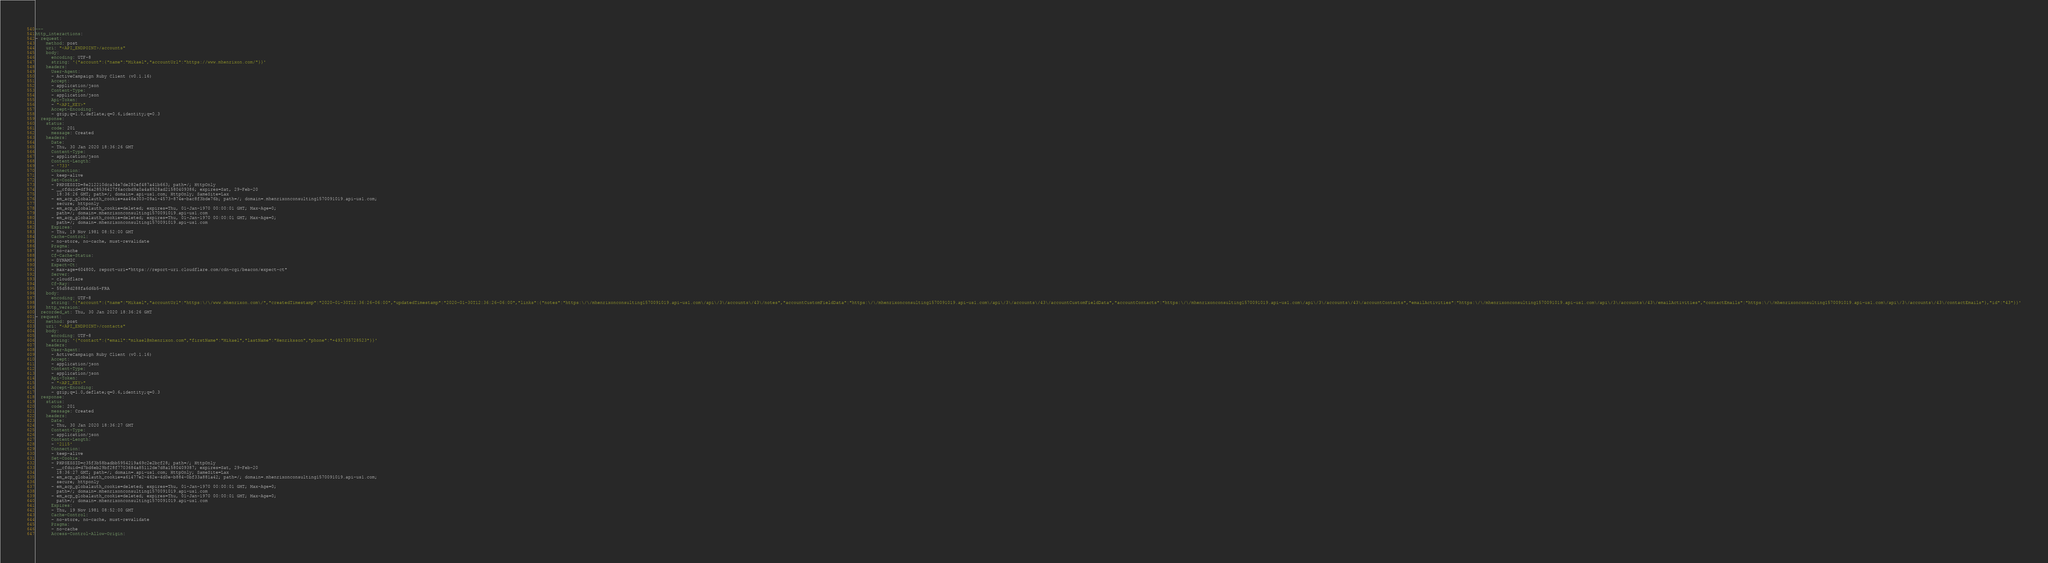<code> <loc_0><loc_0><loc_500><loc_500><_YAML_>---
http_interactions:
- request:
    method: post
    uri: "<API_ENDPOINT>/accounts"
    body:
      encoding: UTF-8
      string: '{"account":{"name":"Mikael","accountUrl":"https://www.mhenrixon.com/"}}'
    headers:
      User-Agent:
      - ActiveCampaign Ruby Client (v0.1.16)
      Accept:
      - application/json
      Content-Type:
      - application/json
      Api-Token:
      - "<API_KEY>"
      Accept-Encoding:
      - gzip;q=1.0,deflate;q=0.6,identity;q=0.3
  response:
    status:
      code: 201
      message: Created
    headers:
      Date:
      - Thu, 30 Jan 2020 18:36:26 GMT
      Content-Type:
      - application/json
      Content-Length:
      - '733'
      Connection:
      - keep-alive
      Set-Cookie:
      - PHPSESSID=8e212210dca34e7de282ef487a41b663; path=/; HttpOnly
      - __cfduid=df94a28536427f6accbd9a0a4a8528ad21580409386; expires=Sat, 29-Feb-20
        18:36:26 GMT; path=/; domain=.api-us1.com; HttpOnly; SameSite=Lax
      - em_acp_globalauth_cookie=aa46e303-09a1-4573-874e-bac8f3bde76b; path=/; domain=.mhenrixonconsulting1570091019.api-us1.com;
        secure; httponly
      - em_acp_globalauth_cookie=deleted; expires=Thu, 01-Jan-1970 00:00:01 GMT; Max-Age=0;
        path=/; domain=.mhenrixonconsulting1570091019.api-us1.com
      - em_acp_globalauth_cookie=deleted; expires=Thu, 01-Jan-1970 00:00:01 GMT; Max-Age=0;
        path=/; domain=.mhenrixonconsulting1570091019.api-us1.com
      Expires:
      - Thu, 19 Nov 1981 08:52:00 GMT
      Cache-Control:
      - no-store, no-cache, must-revalidate
      Pragma:
      - no-cache
      Cf-Cache-Status:
      - DYNAMIC
      Expect-Ct:
      - max-age=604800, report-uri="https://report-uri.cloudflare.com/cdn-cgi/beacon/expect-ct"
      Server:
      - cloudflare
      Cf-Ray:
      - 55d58d288fa6d6b5-FRA
    body:
      encoding: UTF-8
      string: '{"account":{"name":"Mikael","accountUrl":"https:\/\/www.mhenrixon.com\/","createdTimestamp":"2020-01-30T12:36:26-06:00","updatedTimestamp":"2020-01-30T12:36:26-06:00","links":{"notes":"https:\/\/mhenrixonconsulting1570091019.api-us1.com\/api\/3\/accounts\/43\/notes","accountCustomFieldData":"https:\/\/mhenrixonconsulting1570091019.api-us1.com\/api\/3\/accounts\/43\/accountCustomFieldData","accountContacts":"https:\/\/mhenrixonconsulting1570091019.api-us1.com\/api\/3\/accounts\/43\/accountContacts","emailActivities":"https:\/\/mhenrixonconsulting1570091019.api-us1.com\/api\/3\/accounts\/43\/emailActivities","contactEmails":"https:\/\/mhenrixonconsulting1570091019.api-us1.com\/api\/3\/accounts\/43\/contactEmails"},"id":"43"}}'
    http_version: 
  recorded_at: Thu, 30 Jan 2020 18:36:26 GMT
- request:
    method: post
    uri: "<API_ENDPOINT>/contacts"
    body:
      encoding: UTF-8
      string: '{"contact":{"email":"mikael@mhenrixon.com","firstName":"Mikael","lastName":"Henriksson","phone":"+491735728523"}}'
    headers:
      User-Agent:
      - ActiveCampaign Ruby Client (v0.1.16)
      Accept:
      - application/json
      Content-Type:
      - application/json
      Api-Token:
      - "<API_KEY>"
      Accept-Encoding:
      - gzip;q=1.0,deflate;q=0.6,identity;q=0.3
  response:
    status:
      code: 201
      message: Created
    headers:
      Date:
      - Thu, 30 Jan 2020 18:36:27 GMT
      Content-Type:
      - application/json
      Content-Length:
      - '2115'
      Connection:
      - keep-alive
      Set-Cookie:
      - PHPSESSID=c35f3b58badbb5954219a69c2e2bcf28; path=/; HttpOnly
      - __cfduid=d7bd6eb29bf28f7703684a85112de7d8a1580409387; expires=Sat, 29-Feb-20
        18:36:27 GMT; path=/; domain=.api-us1.com; HttpOnly; SameSite=Lax
      - em_acp_globalauth_cookie=a61477e2-462e-4d0e-b884-0bf33a881a42; path=/; domain=.mhenrixonconsulting1570091019.api-us1.com;
        secure; httponly
      - em_acp_globalauth_cookie=deleted; expires=Thu, 01-Jan-1970 00:00:01 GMT; Max-Age=0;
        path=/; domain=.mhenrixonconsulting1570091019.api-us1.com
      - em_acp_globalauth_cookie=deleted; expires=Thu, 01-Jan-1970 00:00:01 GMT; Max-Age=0;
        path=/; domain=.mhenrixonconsulting1570091019.api-us1.com
      Expires:
      - Thu, 19 Nov 1981 08:52:00 GMT
      Cache-Control:
      - no-store, no-cache, must-revalidate
      Pragma:
      - no-cache
      Access-Control-Allow-Origin:</code> 